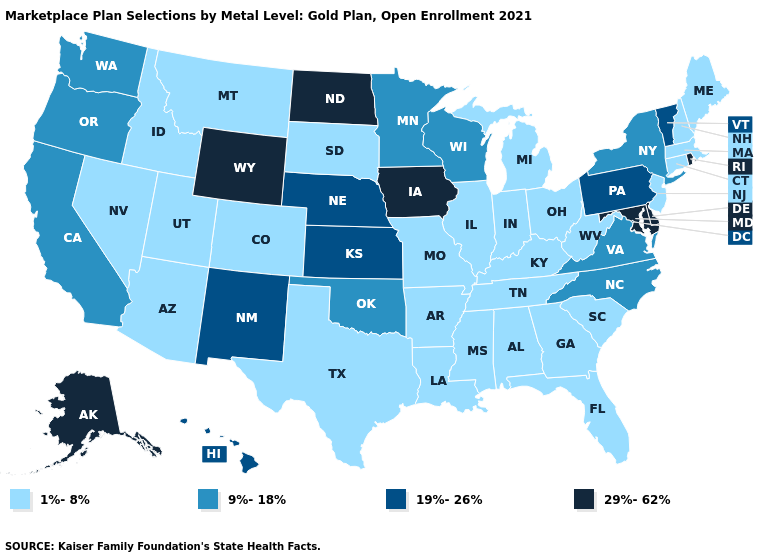Does Wyoming have the same value as Kansas?
Write a very short answer. No. Does Arkansas have the lowest value in the South?
Be succinct. Yes. Name the states that have a value in the range 9%-18%?
Write a very short answer. California, Minnesota, New York, North Carolina, Oklahoma, Oregon, Virginia, Washington, Wisconsin. Among the states that border New Jersey , which have the lowest value?
Give a very brief answer. New York. What is the value of Virginia?
Short answer required. 9%-18%. What is the lowest value in states that border Missouri?
Give a very brief answer. 1%-8%. Which states have the highest value in the USA?
Write a very short answer. Alaska, Delaware, Iowa, Maryland, North Dakota, Rhode Island, Wyoming. Does Vermont have a lower value than Alaska?
Quick response, please. Yes. Does Colorado have the lowest value in the USA?
Write a very short answer. Yes. Name the states that have a value in the range 1%-8%?
Answer briefly. Alabama, Arizona, Arkansas, Colorado, Connecticut, Florida, Georgia, Idaho, Illinois, Indiana, Kentucky, Louisiana, Maine, Massachusetts, Michigan, Mississippi, Missouri, Montana, Nevada, New Hampshire, New Jersey, Ohio, South Carolina, South Dakota, Tennessee, Texas, Utah, West Virginia. Name the states that have a value in the range 29%-62%?
Keep it brief. Alaska, Delaware, Iowa, Maryland, North Dakota, Rhode Island, Wyoming. Among the states that border Washington , which have the lowest value?
Short answer required. Idaho. Name the states that have a value in the range 1%-8%?
Write a very short answer. Alabama, Arizona, Arkansas, Colorado, Connecticut, Florida, Georgia, Idaho, Illinois, Indiana, Kentucky, Louisiana, Maine, Massachusetts, Michigan, Mississippi, Missouri, Montana, Nevada, New Hampshire, New Jersey, Ohio, South Carolina, South Dakota, Tennessee, Texas, Utah, West Virginia. What is the value of Indiana?
Keep it brief. 1%-8%. Is the legend a continuous bar?
Keep it brief. No. 